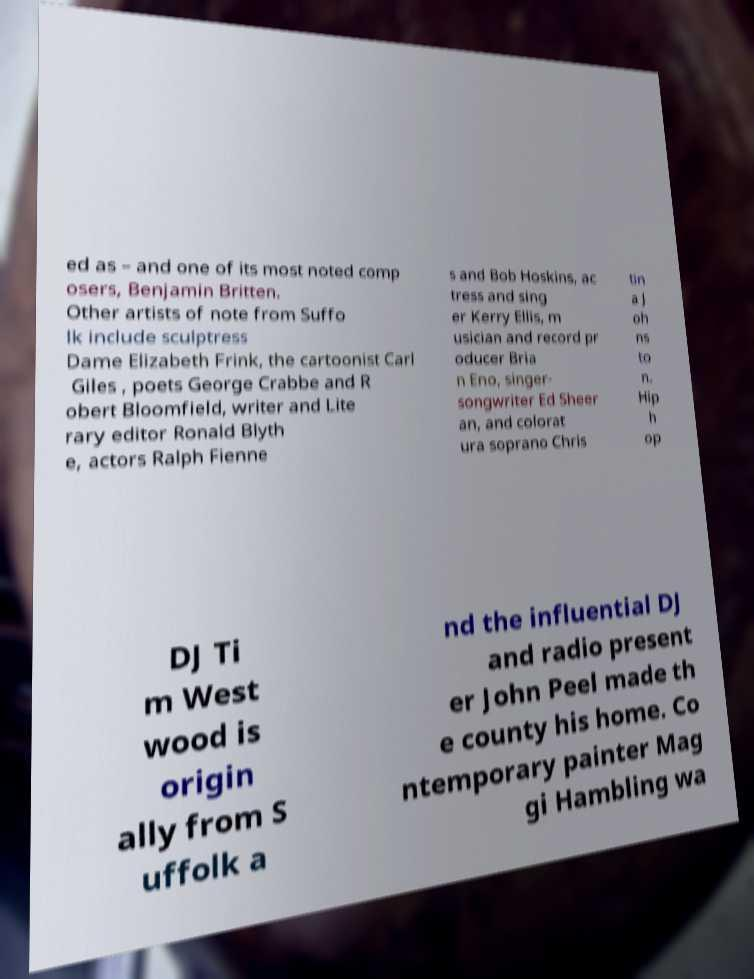Could you extract and type out the text from this image? ed as – and one of its most noted comp osers, Benjamin Britten. Other artists of note from Suffo lk include sculptress Dame Elizabeth Frink, the cartoonist Carl Giles , poets George Crabbe and R obert Bloomfield, writer and Lite rary editor Ronald Blyth e, actors Ralph Fienne s and Bob Hoskins, ac tress and sing er Kerry Ellis, m usician and record pr oducer Bria n Eno, singer- songwriter Ed Sheer an, and colorat ura soprano Chris tin a J oh ns to n. Hip h op DJ Ti m West wood is origin ally from S uffolk a nd the influential DJ and radio present er John Peel made th e county his home. Co ntemporary painter Mag gi Hambling wa 